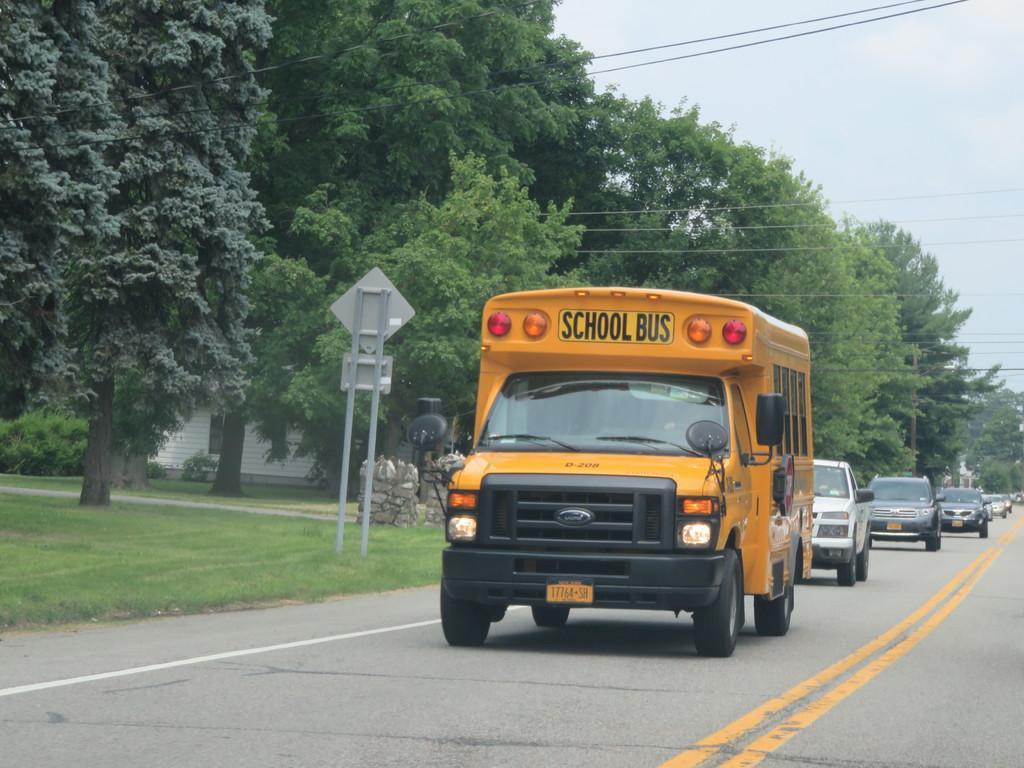Describe this image in one or two sentences. In this image, we can see few vehicles are on the road. Background we can see grass, boards with poles, trees, house, glass window, wires. Top of the image, there is a sky. 